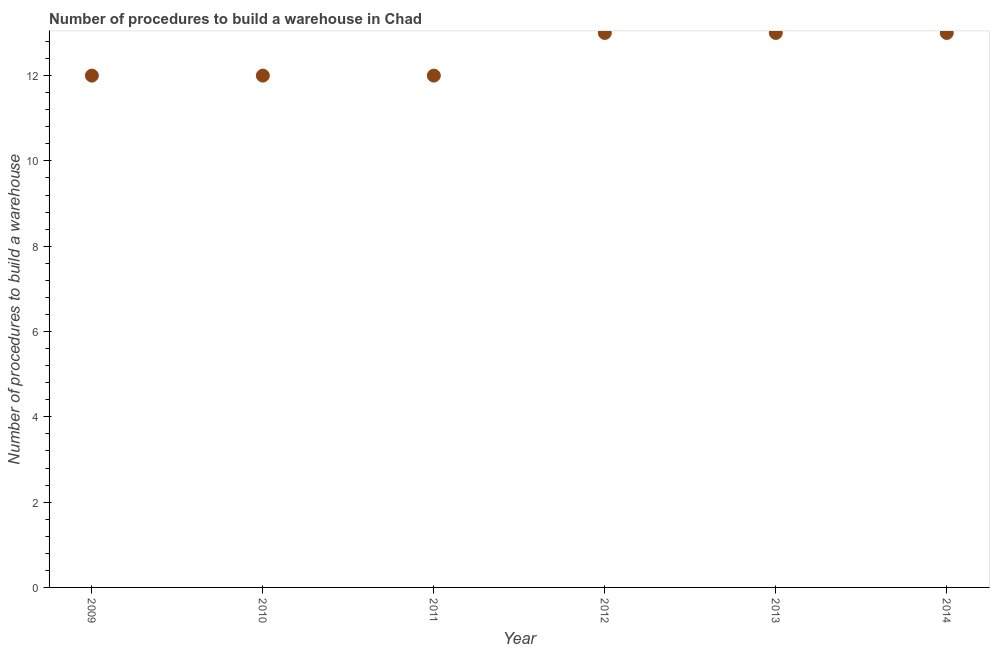What is the number of procedures to build a warehouse in 2009?
Offer a terse response. 12. Across all years, what is the maximum number of procedures to build a warehouse?
Offer a terse response. 13. Across all years, what is the minimum number of procedures to build a warehouse?
Ensure brevity in your answer.  12. In which year was the number of procedures to build a warehouse minimum?
Your response must be concise. 2009. What is the sum of the number of procedures to build a warehouse?
Offer a very short reply. 75. What is the difference between the number of procedures to build a warehouse in 2013 and 2014?
Offer a terse response. 0. What is the median number of procedures to build a warehouse?
Provide a succinct answer. 12.5. In how many years, is the number of procedures to build a warehouse greater than 3.2 ?
Provide a succinct answer. 6. Do a majority of the years between 2009 and 2014 (inclusive) have number of procedures to build a warehouse greater than 5.6 ?
Your response must be concise. Yes. What is the ratio of the number of procedures to build a warehouse in 2011 to that in 2013?
Offer a terse response. 0.92. Is the number of procedures to build a warehouse in 2013 less than that in 2014?
Your answer should be very brief. No. What is the difference between the highest and the second highest number of procedures to build a warehouse?
Offer a terse response. 0. Is the sum of the number of procedures to build a warehouse in 2011 and 2014 greater than the maximum number of procedures to build a warehouse across all years?
Keep it short and to the point. Yes. What is the difference between the highest and the lowest number of procedures to build a warehouse?
Keep it short and to the point. 1. Does the number of procedures to build a warehouse monotonically increase over the years?
Offer a terse response. No. How many years are there in the graph?
Ensure brevity in your answer.  6. What is the difference between two consecutive major ticks on the Y-axis?
Offer a very short reply. 2. Are the values on the major ticks of Y-axis written in scientific E-notation?
Your answer should be very brief. No. Does the graph contain grids?
Your answer should be compact. No. What is the title of the graph?
Ensure brevity in your answer.  Number of procedures to build a warehouse in Chad. What is the label or title of the Y-axis?
Give a very brief answer. Number of procedures to build a warehouse. What is the Number of procedures to build a warehouse in 2009?
Give a very brief answer. 12. What is the Number of procedures to build a warehouse in 2012?
Offer a very short reply. 13. What is the Number of procedures to build a warehouse in 2013?
Offer a very short reply. 13. What is the Number of procedures to build a warehouse in 2014?
Ensure brevity in your answer.  13. What is the difference between the Number of procedures to build a warehouse in 2009 and 2010?
Offer a terse response. 0. What is the difference between the Number of procedures to build a warehouse in 2009 and 2011?
Provide a short and direct response. 0. What is the difference between the Number of procedures to build a warehouse in 2009 and 2012?
Your answer should be compact. -1. What is the difference between the Number of procedures to build a warehouse in 2010 and 2011?
Offer a very short reply. 0. What is the difference between the Number of procedures to build a warehouse in 2010 and 2012?
Give a very brief answer. -1. What is the difference between the Number of procedures to build a warehouse in 2010 and 2013?
Provide a short and direct response. -1. What is the difference between the Number of procedures to build a warehouse in 2010 and 2014?
Give a very brief answer. -1. What is the difference between the Number of procedures to build a warehouse in 2011 and 2013?
Provide a succinct answer. -1. What is the difference between the Number of procedures to build a warehouse in 2012 and 2013?
Ensure brevity in your answer.  0. What is the ratio of the Number of procedures to build a warehouse in 2009 to that in 2010?
Your answer should be very brief. 1. What is the ratio of the Number of procedures to build a warehouse in 2009 to that in 2011?
Ensure brevity in your answer.  1. What is the ratio of the Number of procedures to build a warehouse in 2009 to that in 2012?
Offer a terse response. 0.92. What is the ratio of the Number of procedures to build a warehouse in 2009 to that in 2013?
Give a very brief answer. 0.92. What is the ratio of the Number of procedures to build a warehouse in 2009 to that in 2014?
Make the answer very short. 0.92. What is the ratio of the Number of procedures to build a warehouse in 2010 to that in 2011?
Your answer should be compact. 1. What is the ratio of the Number of procedures to build a warehouse in 2010 to that in 2012?
Keep it short and to the point. 0.92. What is the ratio of the Number of procedures to build a warehouse in 2010 to that in 2013?
Your response must be concise. 0.92. What is the ratio of the Number of procedures to build a warehouse in 2010 to that in 2014?
Give a very brief answer. 0.92. What is the ratio of the Number of procedures to build a warehouse in 2011 to that in 2012?
Provide a short and direct response. 0.92. What is the ratio of the Number of procedures to build a warehouse in 2011 to that in 2013?
Offer a very short reply. 0.92. What is the ratio of the Number of procedures to build a warehouse in 2011 to that in 2014?
Make the answer very short. 0.92. What is the ratio of the Number of procedures to build a warehouse in 2012 to that in 2013?
Ensure brevity in your answer.  1. What is the ratio of the Number of procedures to build a warehouse in 2013 to that in 2014?
Make the answer very short. 1. 